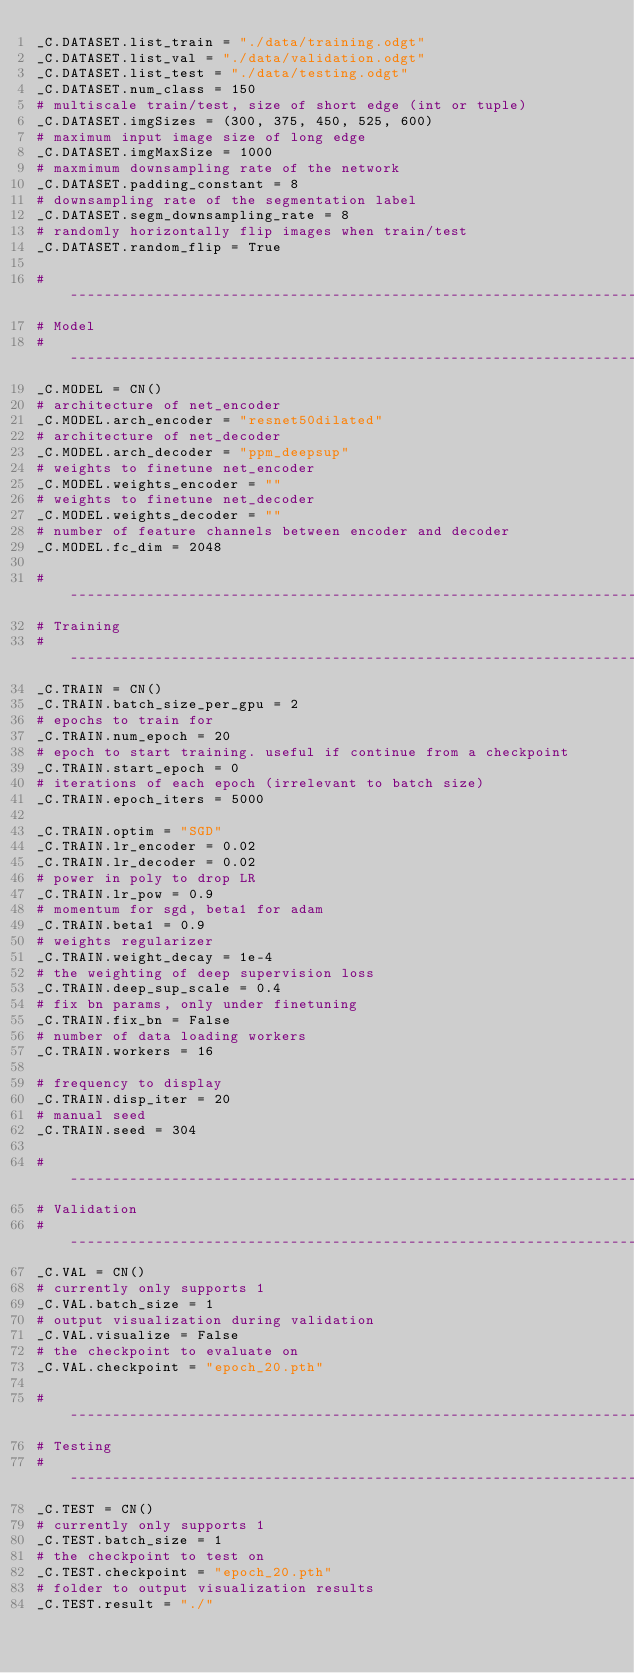Convert code to text. <code><loc_0><loc_0><loc_500><loc_500><_Python_>_C.DATASET.list_train = "./data/training.odgt"
_C.DATASET.list_val = "./data/validation.odgt"
_C.DATASET.list_test = "./data/testing.odgt"
_C.DATASET.num_class = 150
# multiscale train/test, size of short edge (int or tuple)
_C.DATASET.imgSizes = (300, 375, 450, 525, 600)
# maximum input image size of long edge
_C.DATASET.imgMaxSize = 1000
# maxmimum downsampling rate of the network
_C.DATASET.padding_constant = 8
# downsampling rate of the segmentation label
_C.DATASET.segm_downsampling_rate = 8
# randomly horizontally flip images when train/test
_C.DATASET.random_flip = True

# -----------------------------------------------------------------------------
# Model
# -----------------------------------------------------------------------------
_C.MODEL = CN()
# architecture of net_encoder
_C.MODEL.arch_encoder = "resnet50dilated"
# architecture of net_decoder
_C.MODEL.arch_decoder = "ppm_deepsup"
# weights to finetune net_encoder
_C.MODEL.weights_encoder = ""
# weights to finetune net_decoder
_C.MODEL.weights_decoder = ""
# number of feature channels between encoder and decoder
_C.MODEL.fc_dim = 2048

# -----------------------------------------------------------------------------
# Training
# -----------------------------------------------------------------------------
_C.TRAIN = CN()
_C.TRAIN.batch_size_per_gpu = 2
# epochs to train for
_C.TRAIN.num_epoch = 20
# epoch to start training. useful if continue from a checkpoint
_C.TRAIN.start_epoch = 0
# iterations of each epoch (irrelevant to batch size)
_C.TRAIN.epoch_iters = 5000

_C.TRAIN.optim = "SGD"
_C.TRAIN.lr_encoder = 0.02
_C.TRAIN.lr_decoder = 0.02
# power in poly to drop LR
_C.TRAIN.lr_pow = 0.9
# momentum for sgd, beta1 for adam
_C.TRAIN.beta1 = 0.9
# weights regularizer
_C.TRAIN.weight_decay = 1e-4
# the weighting of deep supervision loss
_C.TRAIN.deep_sup_scale = 0.4
# fix bn params, only under finetuning
_C.TRAIN.fix_bn = False
# number of data loading workers
_C.TRAIN.workers = 16

# frequency to display
_C.TRAIN.disp_iter = 20
# manual seed
_C.TRAIN.seed = 304

# -----------------------------------------------------------------------------
# Validation
# -----------------------------------------------------------------------------
_C.VAL = CN()
# currently only supports 1
_C.VAL.batch_size = 1
# output visualization during validation
_C.VAL.visualize = False
# the checkpoint to evaluate on
_C.VAL.checkpoint = "epoch_20.pth"

# -----------------------------------------------------------------------------
# Testing
# -----------------------------------------------------------------------------
_C.TEST = CN()
# currently only supports 1
_C.TEST.batch_size = 1
# the checkpoint to test on
_C.TEST.checkpoint = "epoch_20.pth"
# folder to output visualization results
_C.TEST.result = "./"
</code> 